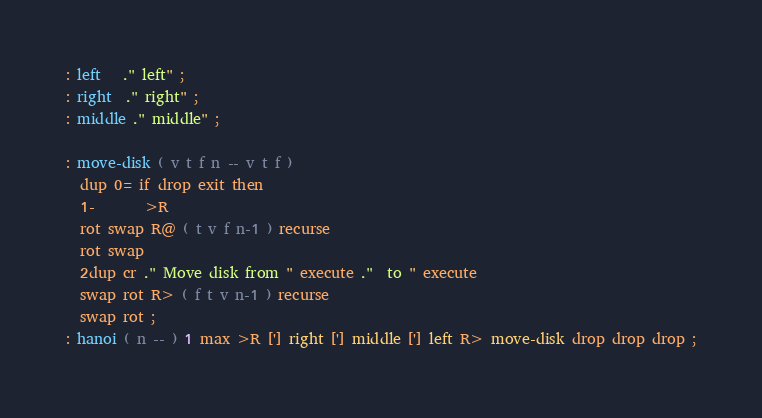Convert code to text. <code><loc_0><loc_0><loc_500><loc_500><_Forth_>: left   ." left" ;
: right  ." right" ;
: middle ." middle" ;
 
: move-disk ( v t f n -- v t f )
  dup 0= if drop exit then
  1-       >R
  rot swap R@ ( t v f n-1 ) recurse
  rot swap
  2dup cr ." Move disk from " execute ."  to " execute
  swap rot R> ( f t v n-1 ) recurse
  swap rot ;
: hanoi ( n -- ) 1 max >R ['] right ['] middle ['] left R> move-disk drop drop drop ;
</code> 